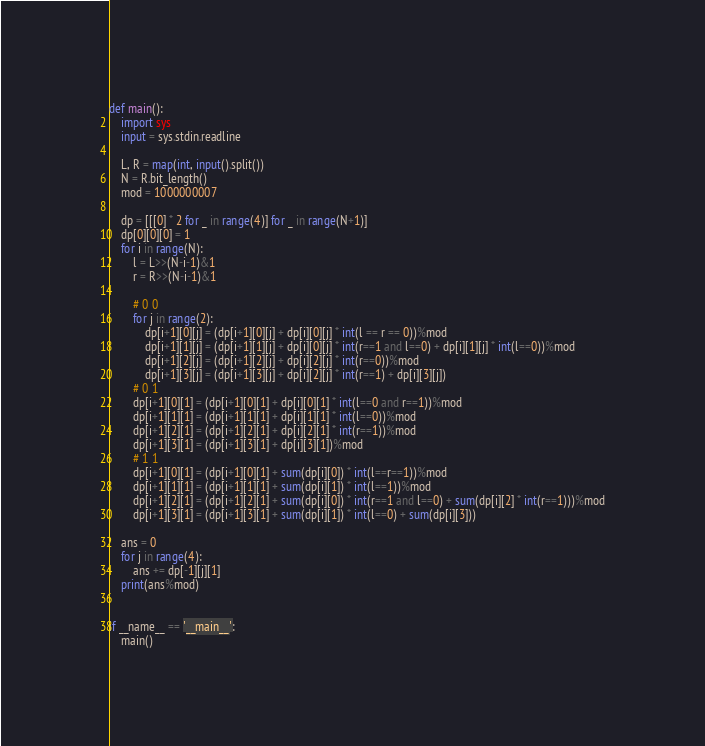Convert code to text. <code><loc_0><loc_0><loc_500><loc_500><_Python_>def main():
    import sys
    input = sys.stdin.readline

    L, R = map(int, input().split())
    N = R.bit_length()
    mod = 1000000007

    dp = [[[0] * 2 for _ in range(4)] for _ in range(N+1)]
    dp[0][0][0] = 1
    for i in range(N):
        l = L>>(N-i-1)&1
        r = R>>(N-i-1)&1

        # 0 0
        for j in range(2):
            dp[i+1][0][j] = (dp[i+1][0][j] + dp[i][0][j] * int(l == r == 0))%mod
            dp[i+1][1][j] = (dp[i+1][1][j] + dp[i][0][j] * int(r==1 and l==0) + dp[i][1][j] * int(l==0))%mod
            dp[i+1][2][j] = (dp[i+1][2][j] + dp[i][2][j] * int(r==0))%mod
            dp[i+1][3][j] = (dp[i+1][3][j] + dp[i][2][j] * int(r==1) + dp[i][3][j])
        # 0 1
        dp[i+1][0][1] = (dp[i+1][0][1] + dp[i][0][1] * int(l==0 and r==1))%mod
        dp[i+1][1][1] = (dp[i+1][1][1] + dp[i][1][1] * int(l==0))%mod
        dp[i+1][2][1] = (dp[i+1][2][1] + dp[i][2][1] * int(r==1))%mod
        dp[i+1][3][1] = (dp[i+1][3][1] + dp[i][3][1])%mod
        # 1 1
        dp[i+1][0][1] = (dp[i+1][0][1] + sum(dp[i][0]) * int(l==r==1))%mod
        dp[i+1][1][1] = (dp[i+1][1][1] + sum(dp[i][1]) * int(l==1))%mod
        dp[i+1][2][1] = (dp[i+1][2][1] + sum(dp[i][0]) * int(r==1 and l==0) + sum(dp[i][2] * int(r==1)))%mod
        dp[i+1][3][1] = (dp[i+1][3][1] + sum(dp[i][1]) * int(l==0) + sum(dp[i][3]))

    ans = 0
    for j in range(4):
        ans += dp[-1][j][1]
    print(ans%mod)


if __name__ == '__main__':
    main()
</code> 